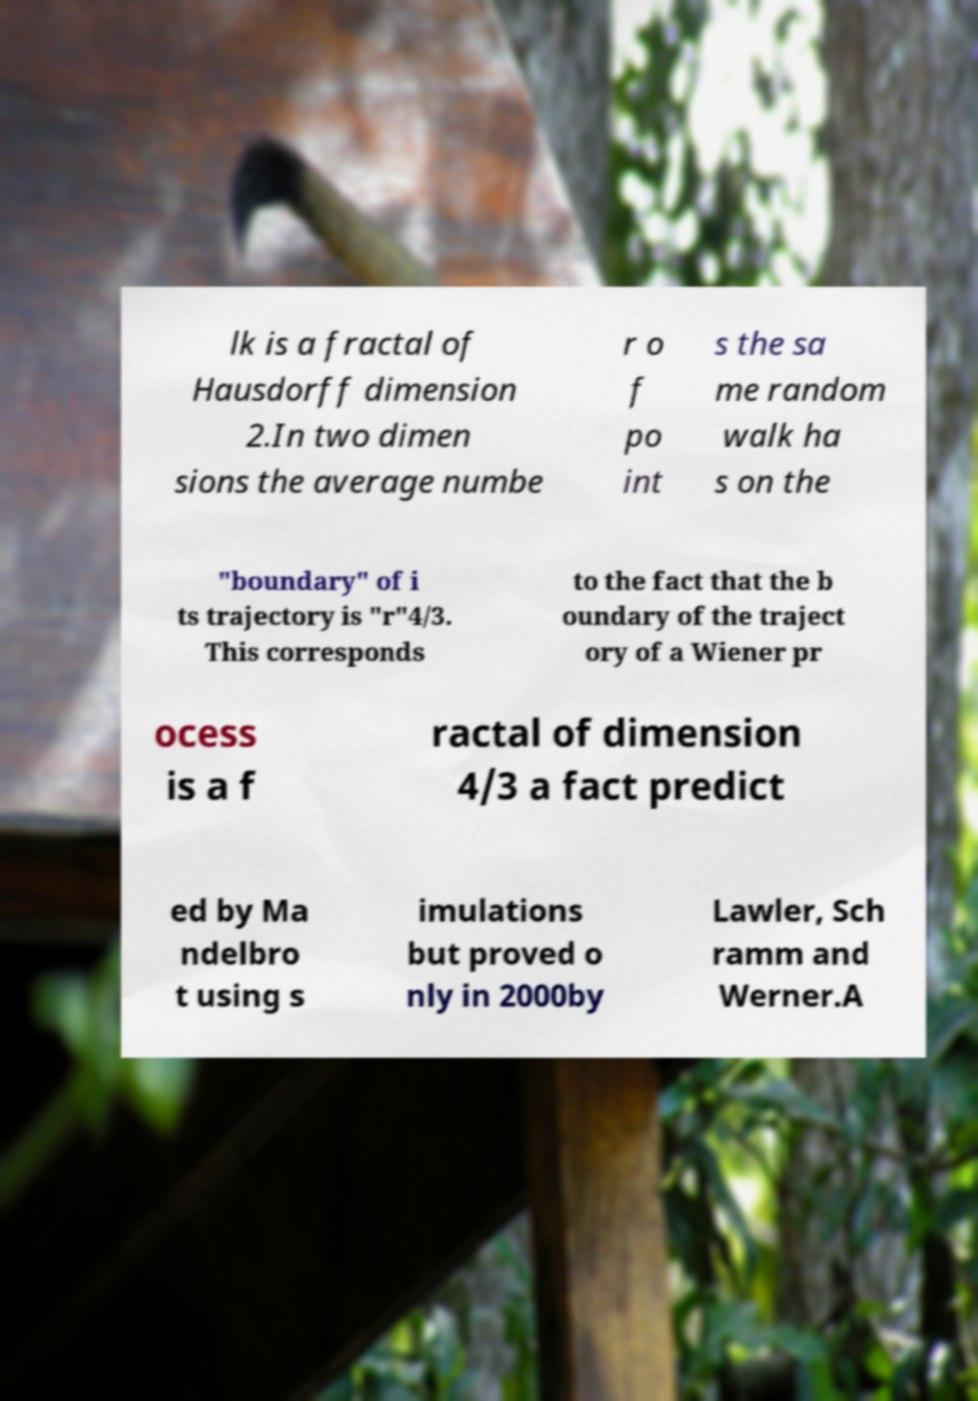What messages or text are displayed in this image? I need them in a readable, typed format. lk is a fractal of Hausdorff dimension 2.In two dimen sions the average numbe r o f po int s the sa me random walk ha s on the "boundary" of i ts trajectory is "r"4/3. This corresponds to the fact that the b oundary of the traject ory of a Wiener pr ocess is a f ractal of dimension 4/3 a fact predict ed by Ma ndelbro t using s imulations but proved o nly in 2000by Lawler, Sch ramm and Werner.A 